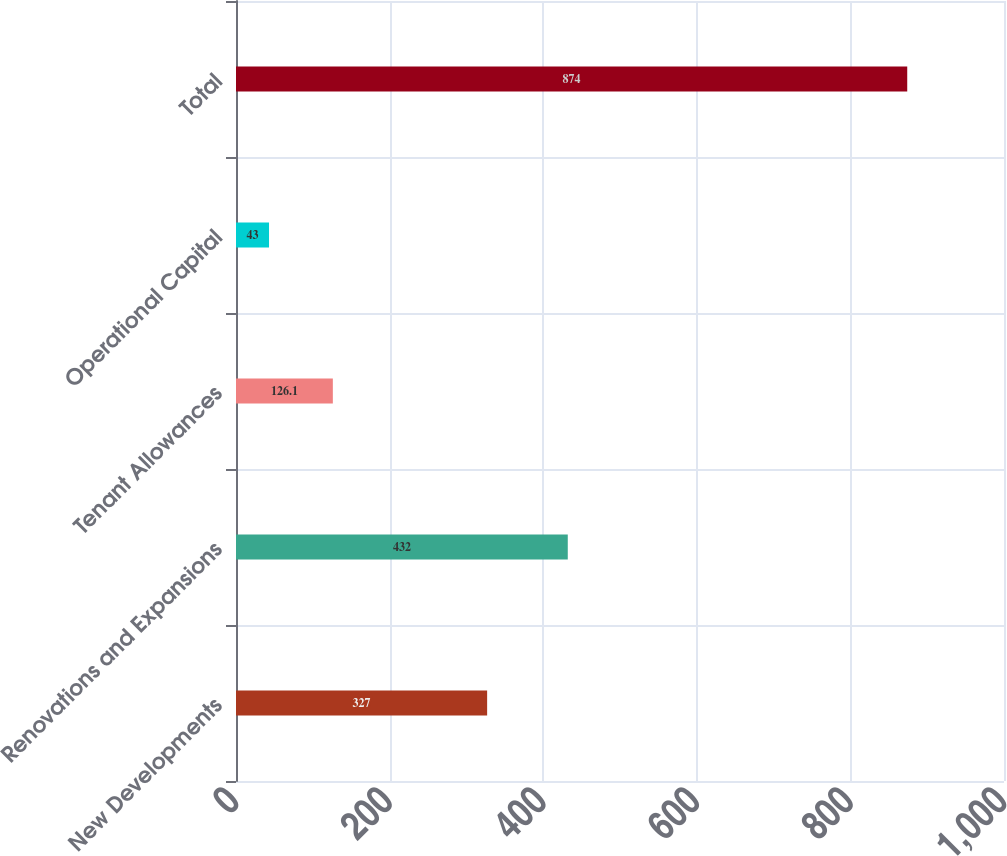Convert chart to OTSL. <chart><loc_0><loc_0><loc_500><loc_500><bar_chart><fcel>New Developments<fcel>Renovations and Expansions<fcel>Tenant Allowances<fcel>Operational Capital<fcel>Total<nl><fcel>327<fcel>432<fcel>126.1<fcel>43<fcel>874<nl></chart> 